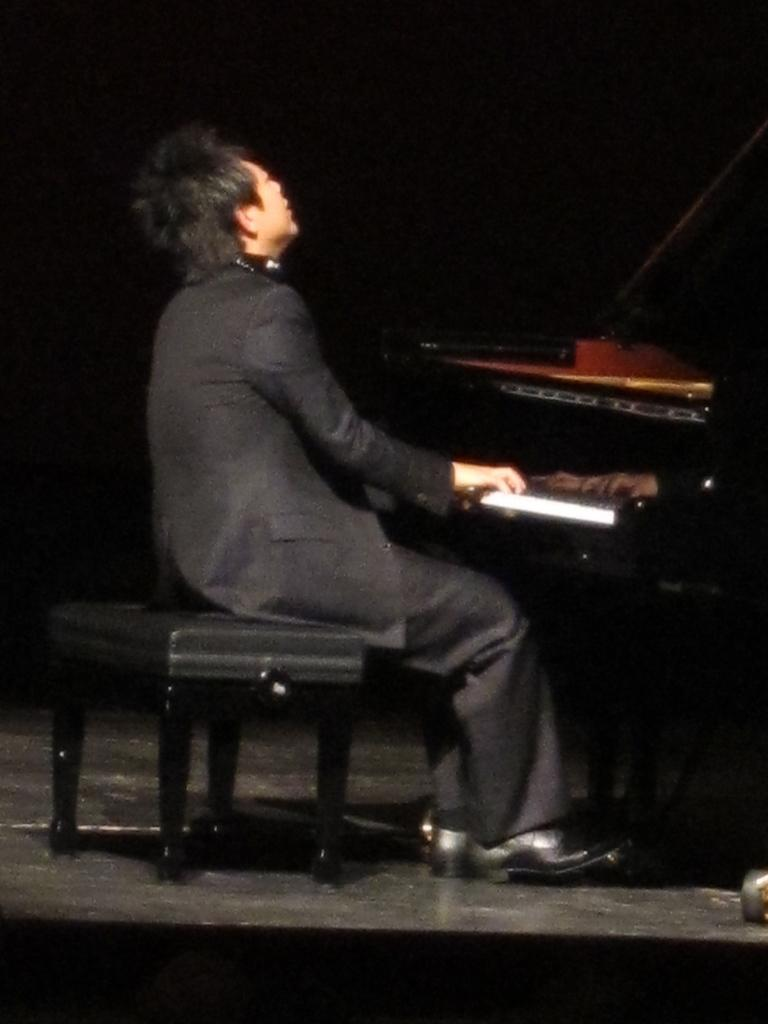Who or what is in the image? There is a person in the image. What is the person doing in the image? The person is sitting on a stool. Where is the stool located in relation to another object in the image? The stool is near a piano. What type of food is the person eating in the image? There is no food present in the image; the person is sitting on a stool near a piano. 